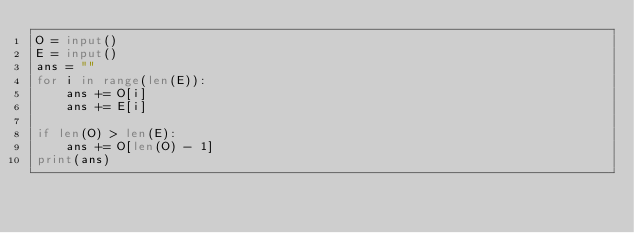Convert code to text. <code><loc_0><loc_0><loc_500><loc_500><_Python_>O = input()
E = input()
ans = ""
for i in range(len(E)):
    ans += O[i]
    ans += E[i]
 
if len(O) > len(E):
    ans += O[len(O) - 1]
print(ans)</code> 